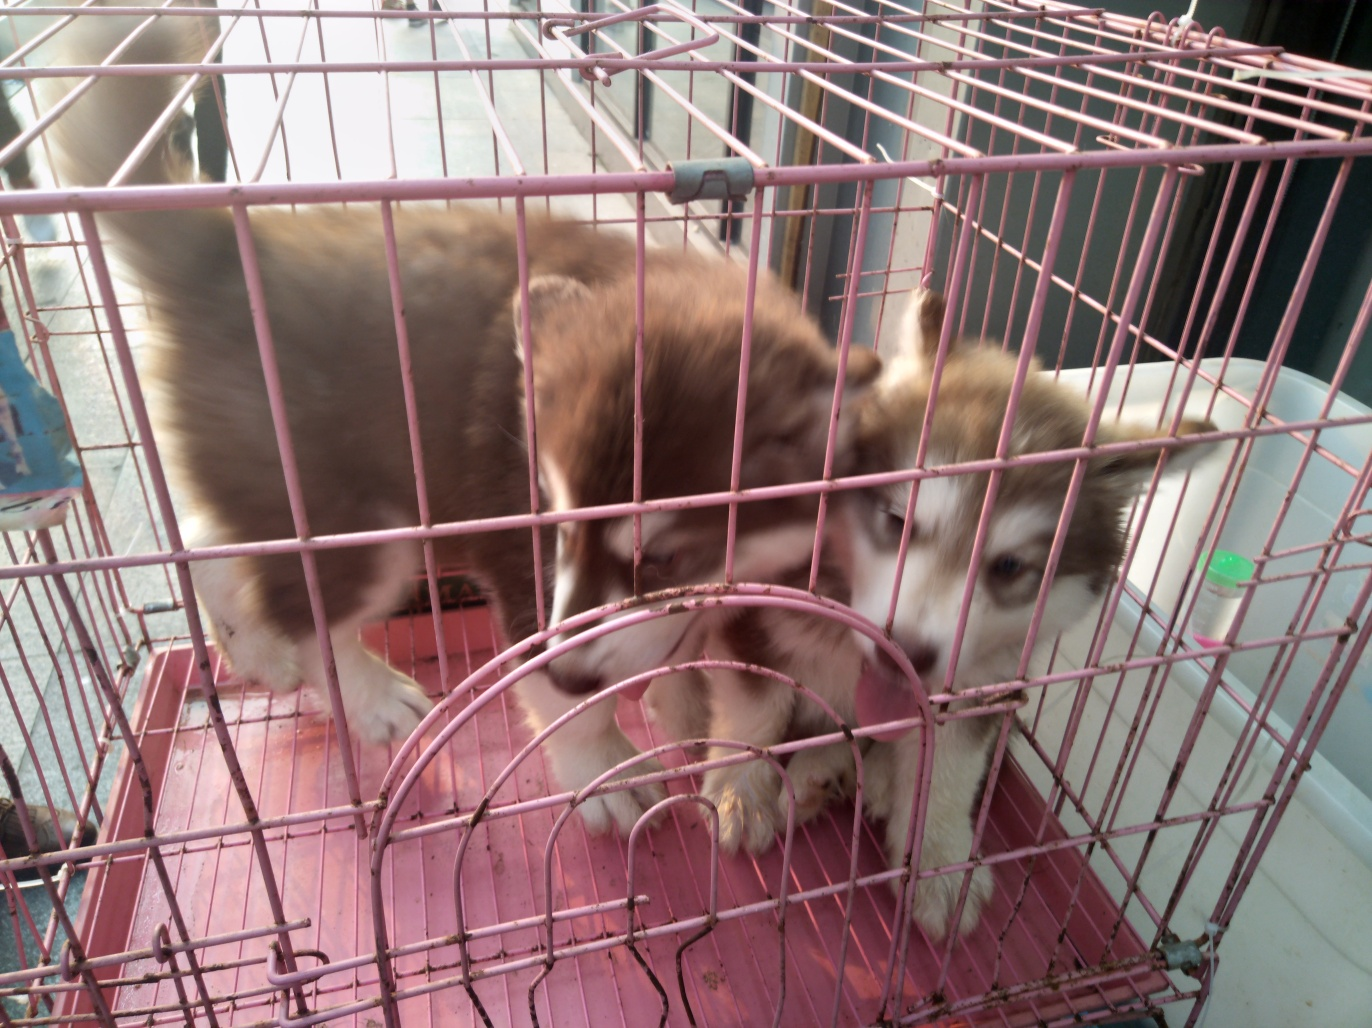Does this image have high quality? The picture provided does not epitomize high quality, as it shows signs of being taken in a hurried manner with a slight blur due to movement, possibly because the subjects, two dogs, are not stationary. The lighting conditions seem suboptimal, and there is evident pixelation, thus the finer details are not as clear as they would be in a high-resolution photograph. 